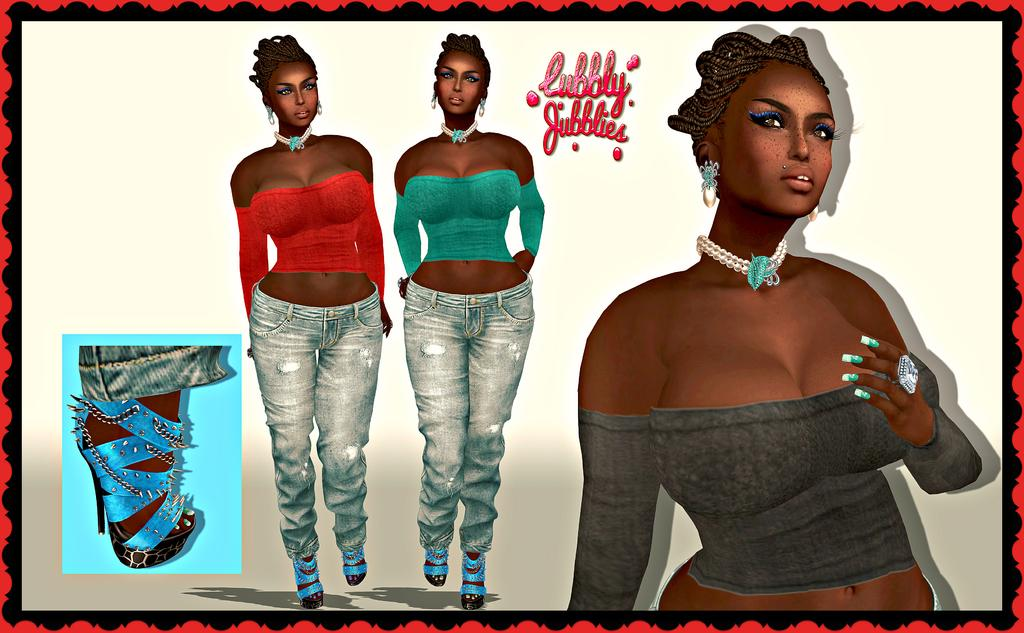What style is the image drawn in? The image is a cartoon. Who is depicted in the image? There are women in the image. What are the women doing in the image? The women are standing. What type of wood is used to build the dock in the image? There is no dock present in the image; it is a cartoon featuring women standing. 